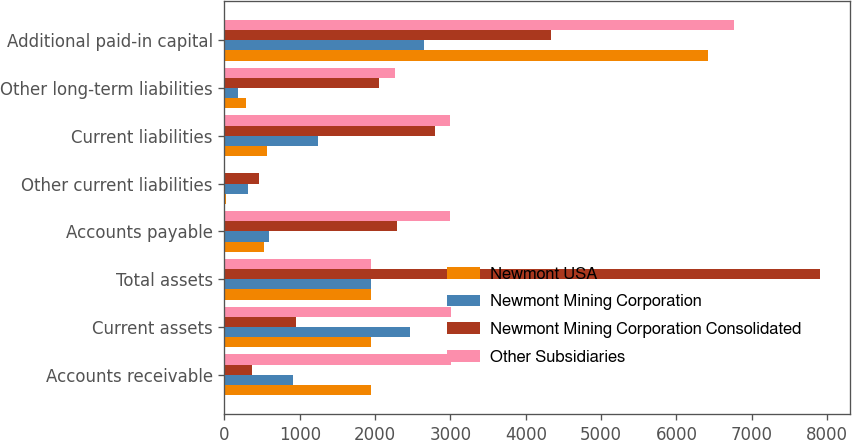Convert chart to OTSL. <chart><loc_0><loc_0><loc_500><loc_500><stacked_bar_chart><ecel><fcel>Accounts receivable<fcel>Current assets<fcel>Total assets<fcel>Accounts payable<fcel>Other current liabilities<fcel>Current liabilities<fcel>Other long-term liabilities<fcel>Additional paid-in capital<nl><fcel>Newmont USA<fcel>1941<fcel>1942<fcel>1942<fcel>524<fcel>15<fcel>560<fcel>283<fcel>6419<nl><fcel>Newmont Mining Corporation<fcel>913<fcel>2465<fcel>1942<fcel>587<fcel>312<fcel>1242<fcel>182<fcel>2647<nl><fcel>Newmont Mining Corporation Consolidated<fcel>370<fcel>955<fcel>7906<fcel>2292<fcel>461<fcel>2794<fcel>2049<fcel>4334<nl><fcel>Other Subsidiaries<fcel>3001<fcel>3001<fcel>1942<fcel>2991<fcel>9<fcel>3000<fcel>2262<fcel>6761<nl></chart> 